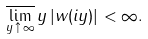<formula> <loc_0><loc_0><loc_500><loc_500>\overline { \lim _ { y \, \uparrow \, \infty } } \, y \, | w ( i y ) | < \infty .</formula> 